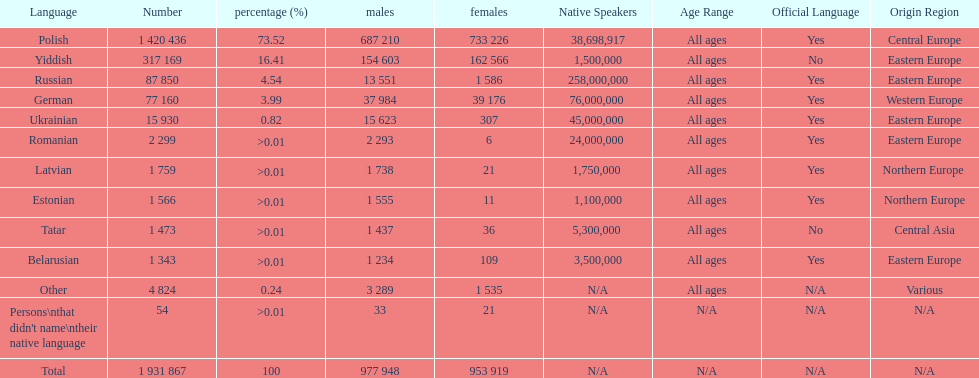What was the next most commonly spoken language in poland after russian? German. 